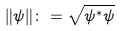Convert formula to latex. <formula><loc_0><loc_0><loc_500><loc_500>\| \psi \| \colon = \sqrt { \psi ^ { * } \psi }</formula> 